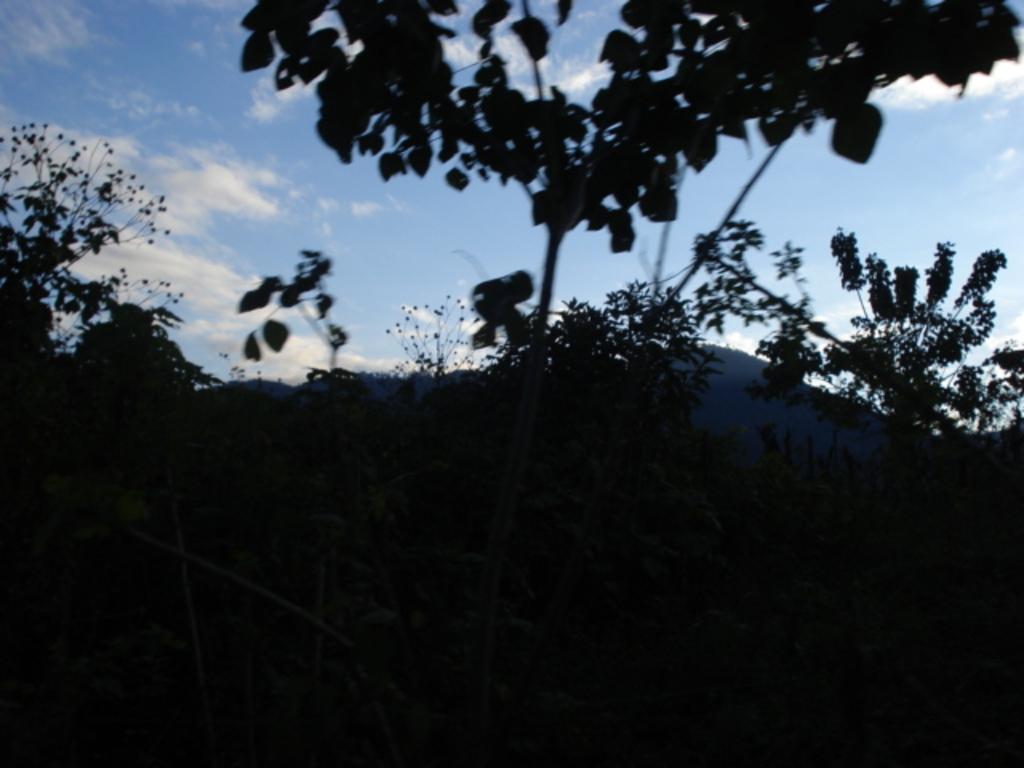Can you describe this image briefly? In this image I see the plants over here and in the background I see the sky which is of white and blue in color and I see that it is dark over here. 